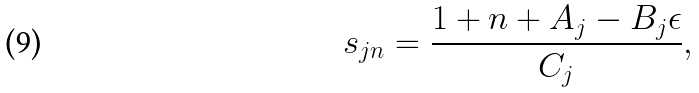<formula> <loc_0><loc_0><loc_500><loc_500>s _ { j n } = \frac { 1 + n + A _ { j } - B _ { j } \epsilon } { C _ { j } } ,</formula> 